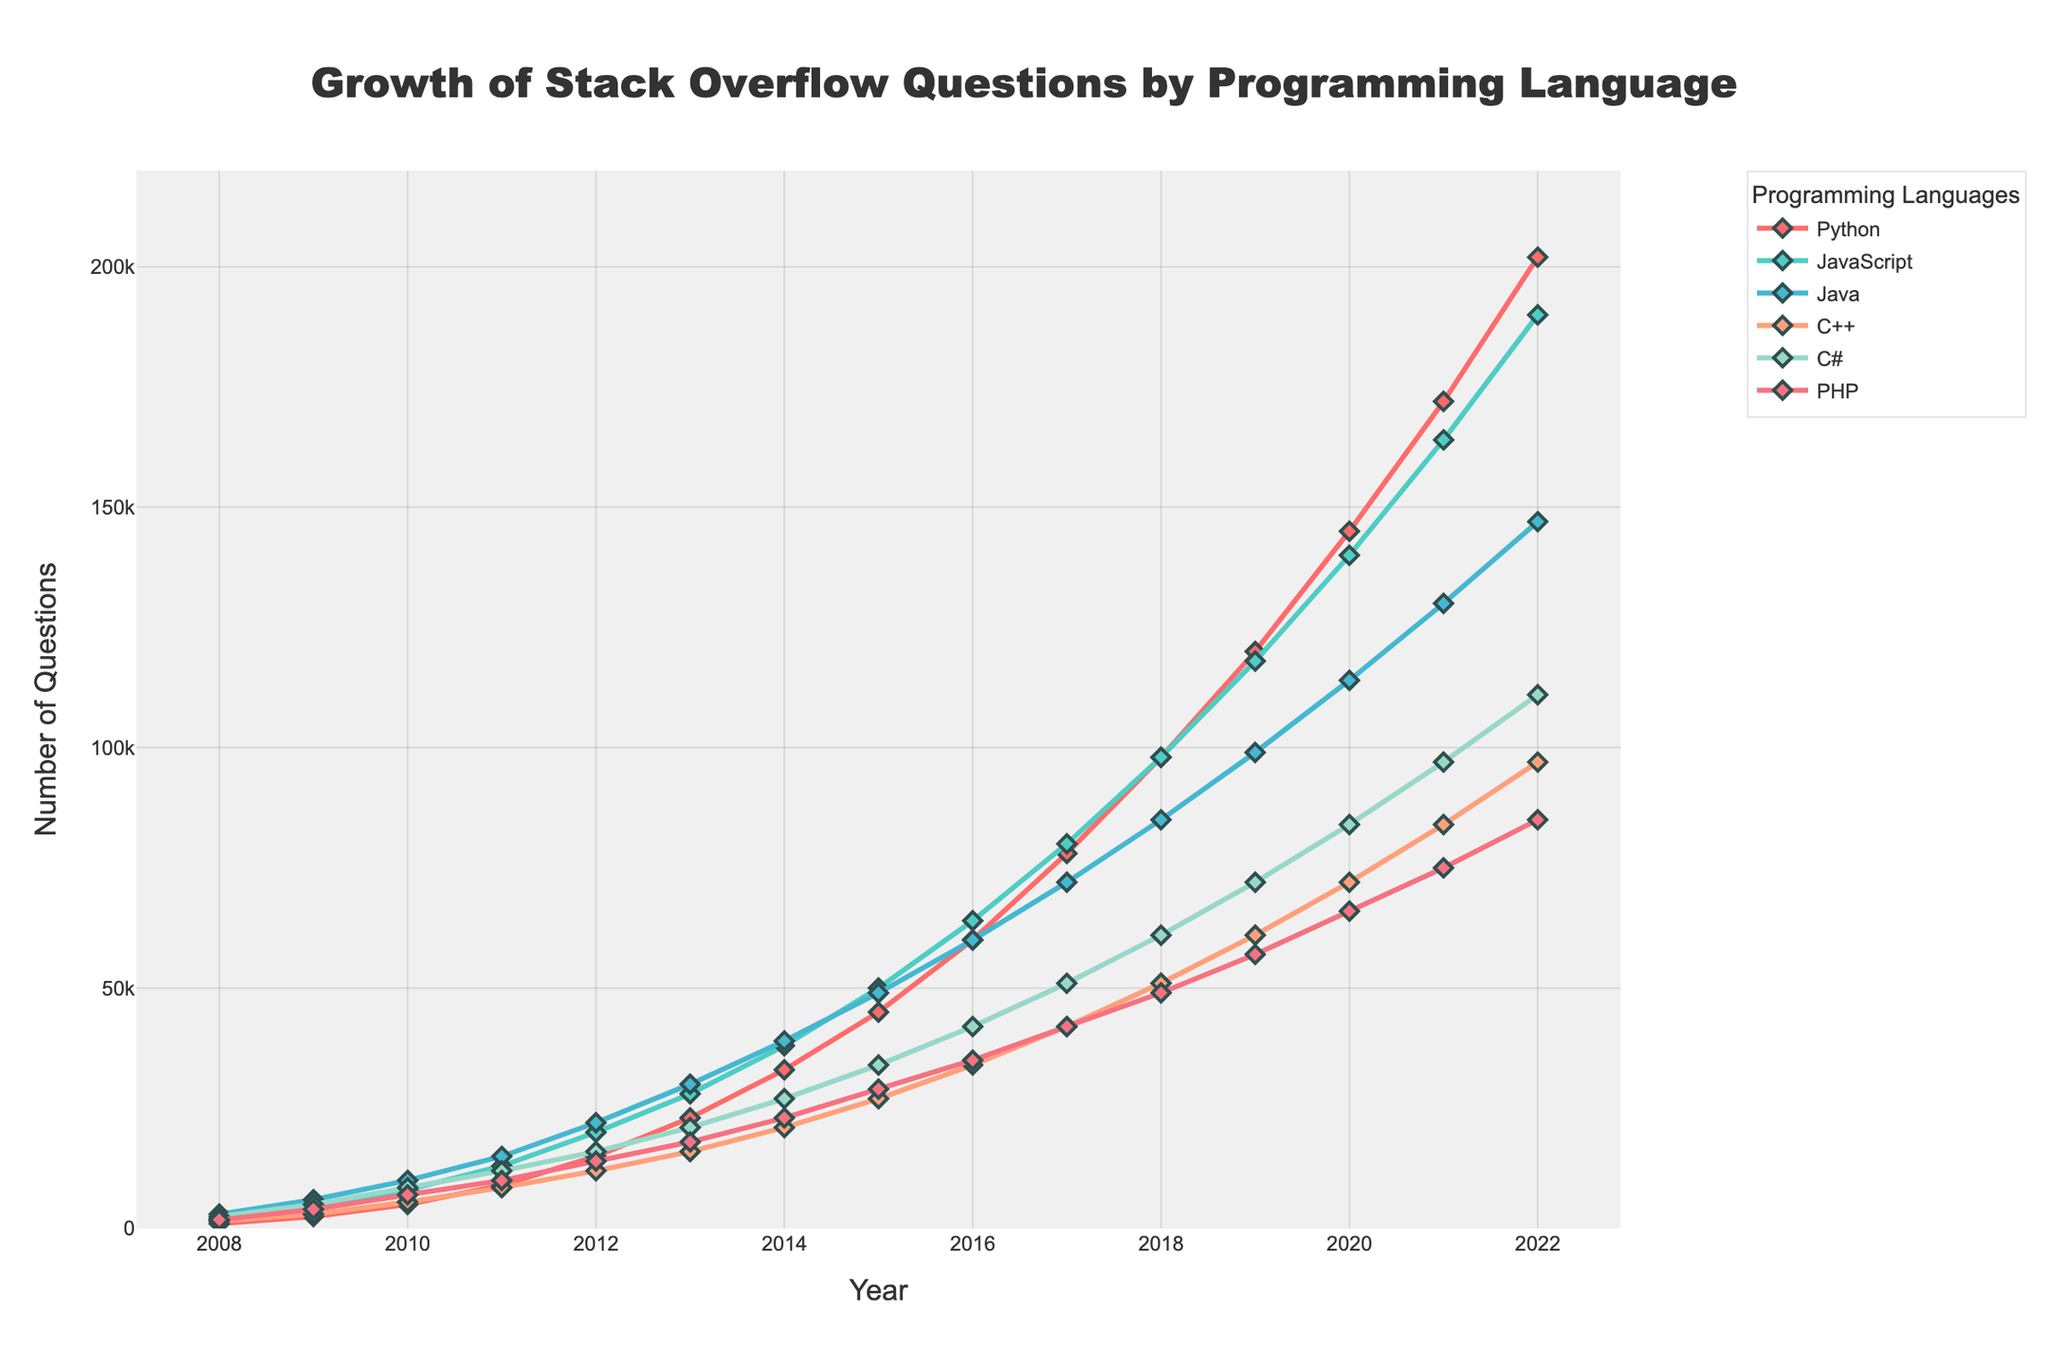Which programming language has the most questions in 2022? By looking at the data plot, the line representing Python in 2022 is higher than the others, indicating that Python has the most questions.
Answer: Python Between which years does JavaScript see the steepest incline in the number of questions? The steepest incline is identified by the sharpest rise in the line representing JavaScript. Between 2009 and 2010, the line shows the steepest rise.
Answer: 2009 to 2010 Compare the number of questions for Java and C++ in 2015. Which had more questions and by how much? The plot shows the points representing Java and C++ in 2015; Java had 49,000 questions and C++ had 27,000 questions. Subtracting the two values, Java has 22,000 more questions than C++.
Answer: Java by 22,000 What is the overall trend of questions for PHP from 2008 to 2022? Observing the line for PHP from 2008 to 2022, there is a consistent upward trend, although not as steep as some other languages.
Answer: Upward trend How many times did Python's question count double from 2008 to 2015? From 2008 with 1,000 questions, Python doubled to at least 2,000 by 2009 and again to 4,500 by 2010. It then doubles roughly in 2013 and one final time by 2015 (to approximately 45,000), indicating three doublings.
Answer: Three times Which language had the slowest growth in terms of questions from 2010 to 2012? From 2010 to 2012, examining the lines, C++ appears to have the slowest growth as its line has the smallest slope compared to others.
Answer: C++ In which year did C# surpass 50,000 questions for the first time? By following the line corresponding to C# and spotting where it first crosses the 50,000 mark, it can be seen that this happens in 2016.
Answer: 2016 What is the combined total number of questions for Java and PHP in 2020? Looking at the figure for both Java and PHP in 2020, Java had 114,000 questions and PHP had 66,000. Adding these together, the combined total is 180,000 questions.
Answer: 180,000 How many more questions did JavaScript receive than Java in 2019? From the figure, JavaScript had 118,000 questions in 2019 and Java had 99,000. The difference is 118,000 - 99,000 = 19,000 questions.
Answer: 19,000 Between Python, JavaScript, and Java, which language had the smallest number of questions in 2008 and by how much less compared to the highest among them? For 2008, Python had 1,000 questions, JavaScript had 2,000, and Java had 3,000. Python had the smallest number of questions, and the difference compared to Java is 3,000 - 1,000 = 2,000.
Answer: Python by 2,000 